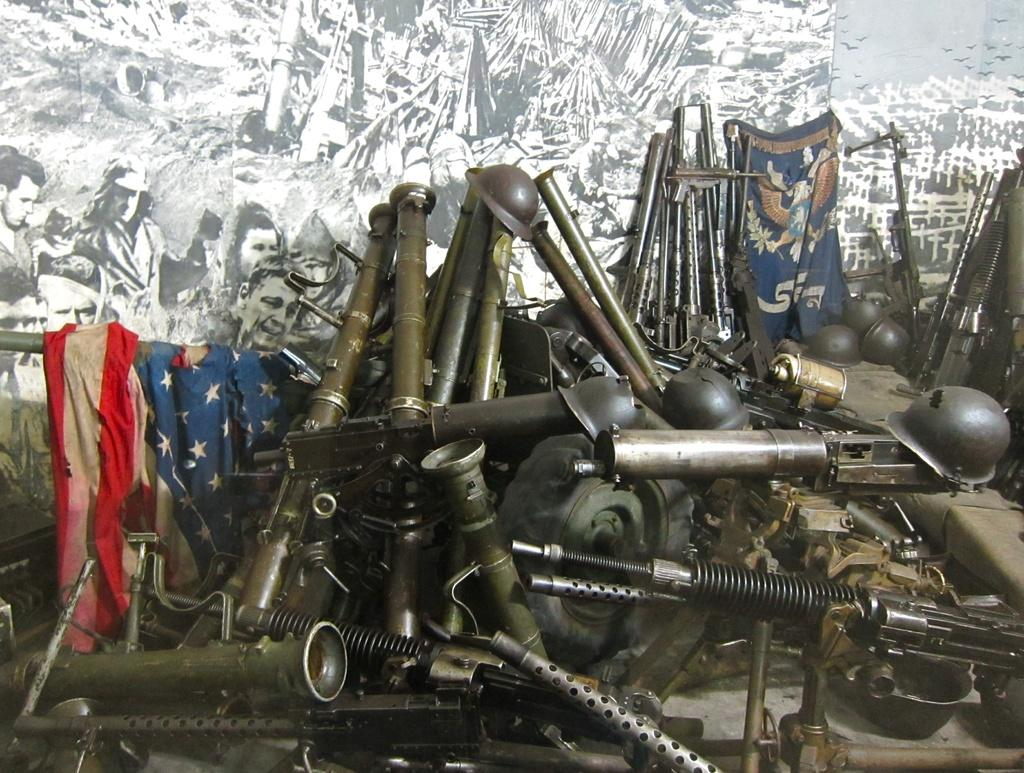What types of objects can be seen in the image? There are different types of weapons and metal helmets in the image. Where are the weapons and helmets located? They are kept in front of a wall. What can be seen on the wall in the image? There are different types of paintings on the wall. What type of polish is being used to shine the weapons in the image? There is no indication in the image that any polish is being used on the weapons. Can you see any toys in the image? There are no toys present in the image. 